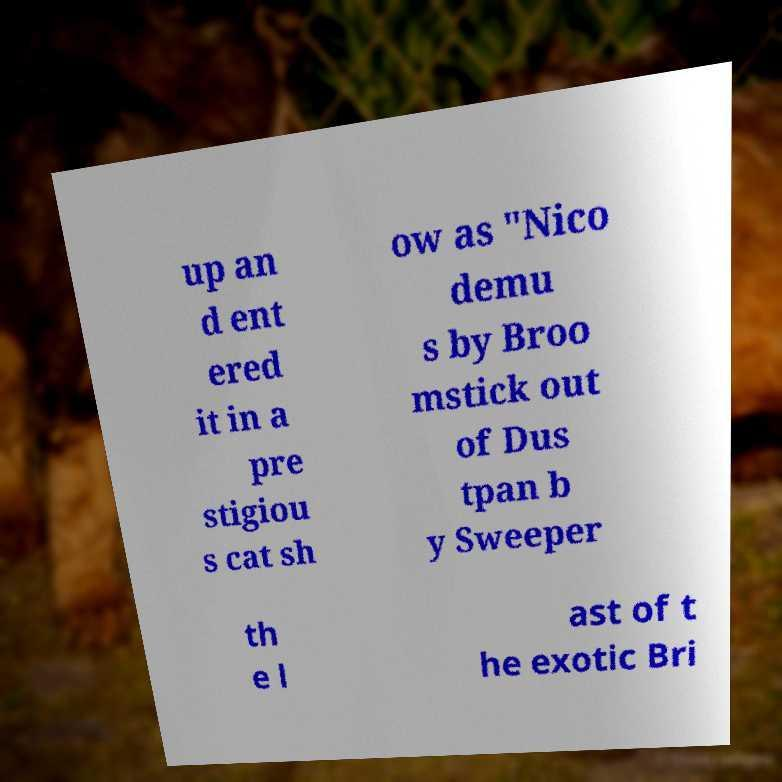Can you read and provide the text displayed in the image?This photo seems to have some interesting text. Can you extract and type it out for me? up an d ent ered it in a pre stigiou s cat sh ow as "Nico demu s by Broo mstick out of Dus tpan b y Sweeper th e l ast of t he exotic Bri 